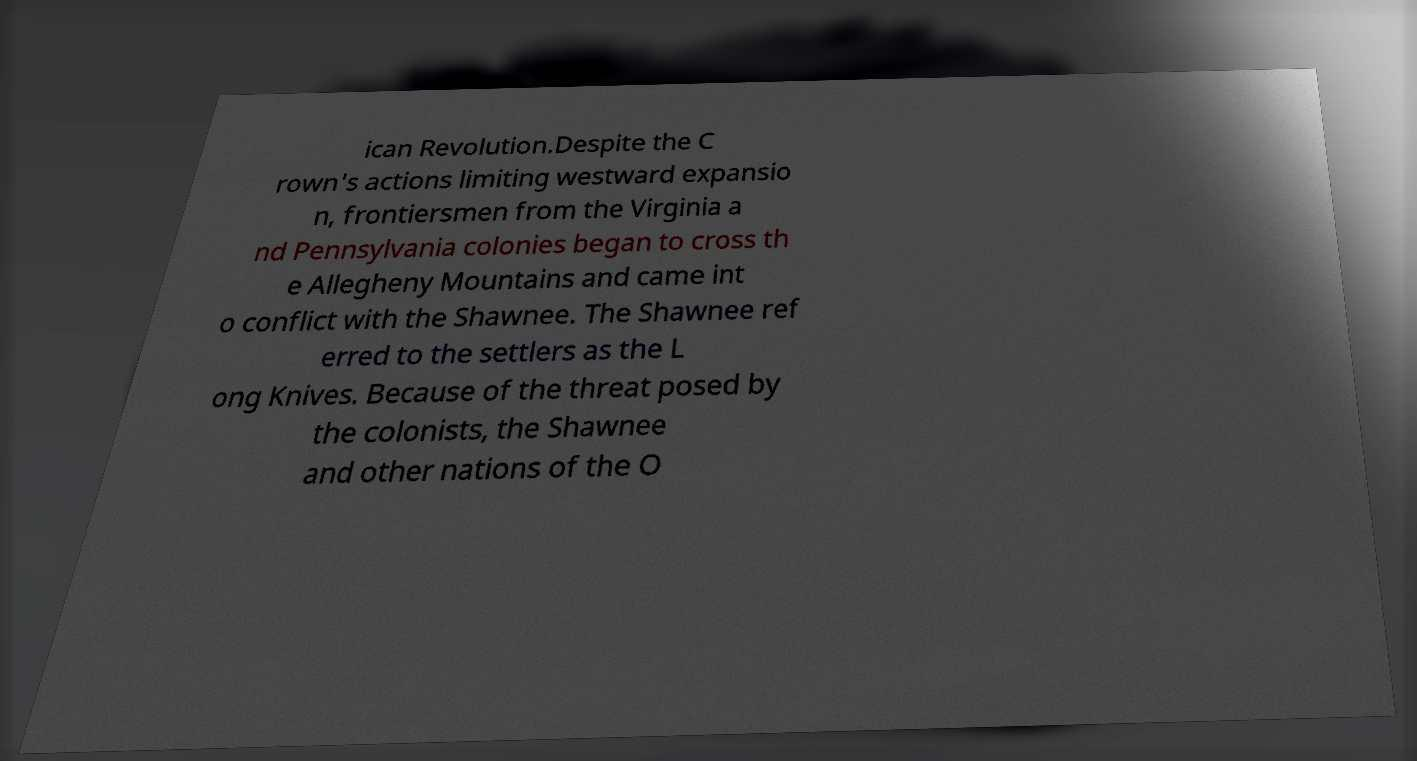Can you accurately transcribe the text from the provided image for me? ican Revolution.Despite the C rown's actions limiting westward expansio n, frontiersmen from the Virginia a nd Pennsylvania colonies began to cross th e Allegheny Mountains and came int o conflict with the Shawnee. The Shawnee ref erred to the settlers as the L ong Knives. Because of the threat posed by the colonists, the Shawnee and other nations of the O 